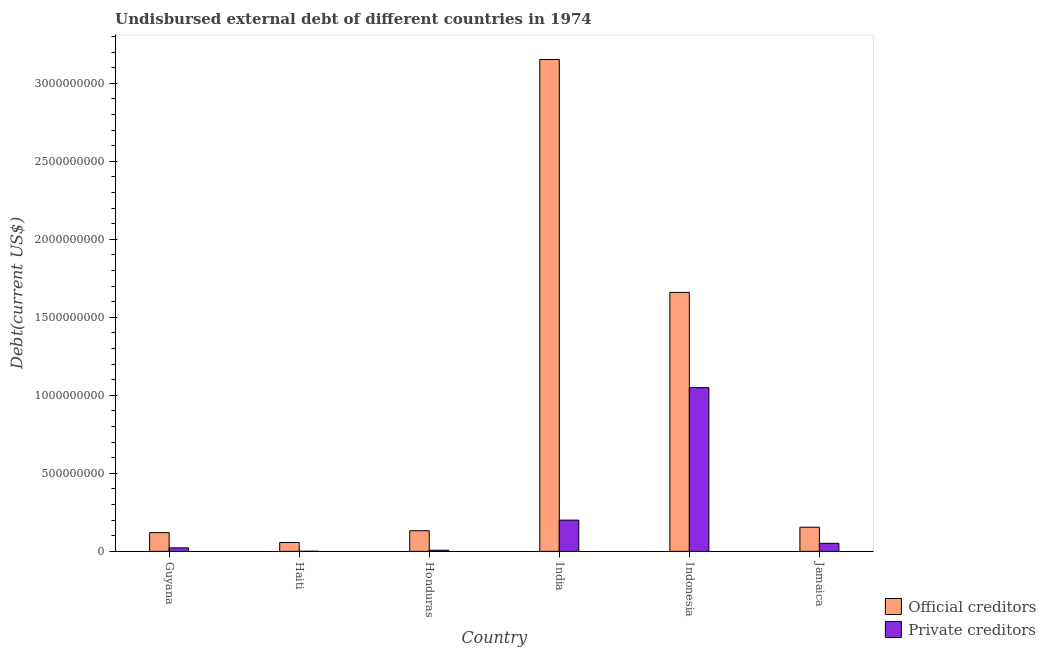How many groups of bars are there?
Keep it short and to the point. 6. Are the number of bars on each tick of the X-axis equal?
Provide a succinct answer. Yes. How many bars are there on the 3rd tick from the left?
Give a very brief answer. 2. How many bars are there on the 6th tick from the right?
Provide a short and direct response. 2. What is the undisbursed external debt of official creditors in India?
Ensure brevity in your answer.  3.15e+09. Across all countries, what is the maximum undisbursed external debt of official creditors?
Your response must be concise. 3.15e+09. Across all countries, what is the minimum undisbursed external debt of official creditors?
Keep it short and to the point. 5.69e+07. In which country was the undisbursed external debt of private creditors minimum?
Provide a succinct answer. Haiti. What is the total undisbursed external debt of official creditors in the graph?
Provide a short and direct response. 5.28e+09. What is the difference between the undisbursed external debt of official creditors in Guyana and that in Jamaica?
Offer a terse response. -3.44e+07. What is the difference between the undisbursed external debt of private creditors in Indonesia and the undisbursed external debt of official creditors in India?
Provide a short and direct response. -2.10e+09. What is the average undisbursed external debt of official creditors per country?
Keep it short and to the point. 8.79e+08. What is the difference between the undisbursed external debt of official creditors and undisbursed external debt of private creditors in Honduras?
Your response must be concise. 1.25e+08. In how many countries, is the undisbursed external debt of private creditors greater than 1200000000 US$?
Give a very brief answer. 0. What is the ratio of the undisbursed external debt of private creditors in Guyana to that in India?
Ensure brevity in your answer.  0.11. Is the difference between the undisbursed external debt of official creditors in Haiti and Honduras greater than the difference between the undisbursed external debt of private creditors in Haiti and Honduras?
Make the answer very short. No. What is the difference between the highest and the second highest undisbursed external debt of official creditors?
Provide a short and direct response. 1.49e+09. What is the difference between the highest and the lowest undisbursed external debt of official creditors?
Ensure brevity in your answer.  3.10e+09. Is the sum of the undisbursed external debt of official creditors in Guyana and Indonesia greater than the maximum undisbursed external debt of private creditors across all countries?
Your response must be concise. Yes. What does the 1st bar from the left in Haiti represents?
Give a very brief answer. Official creditors. What does the 1st bar from the right in Haiti represents?
Make the answer very short. Private creditors. Are all the bars in the graph horizontal?
Offer a terse response. No. How many countries are there in the graph?
Provide a succinct answer. 6. What is the difference between two consecutive major ticks on the Y-axis?
Your answer should be very brief. 5.00e+08. Are the values on the major ticks of Y-axis written in scientific E-notation?
Provide a succinct answer. No. Does the graph contain any zero values?
Give a very brief answer. No. Does the graph contain grids?
Offer a very short reply. No. Where does the legend appear in the graph?
Your answer should be very brief. Bottom right. How are the legend labels stacked?
Your response must be concise. Vertical. What is the title of the graph?
Keep it short and to the point. Undisbursed external debt of different countries in 1974. Does "Age 65(female)" appear as one of the legend labels in the graph?
Your answer should be compact. No. What is the label or title of the Y-axis?
Provide a short and direct response. Debt(current US$). What is the Debt(current US$) of Official creditors in Guyana?
Give a very brief answer. 1.20e+08. What is the Debt(current US$) of Private creditors in Guyana?
Ensure brevity in your answer.  2.25e+07. What is the Debt(current US$) of Official creditors in Haiti?
Your answer should be compact. 5.69e+07. What is the Debt(current US$) of Private creditors in Haiti?
Give a very brief answer. 5.69e+05. What is the Debt(current US$) in Official creditors in Honduras?
Offer a very short reply. 1.32e+08. What is the Debt(current US$) in Private creditors in Honduras?
Offer a very short reply. 7.07e+06. What is the Debt(current US$) of Official creditors in India?
Your answer should be compact. 3.15e+09. What is the Debt(current US$) in Private creditors in India?
Give a very brief answer. 2.00e+08. What is the Debt(current US$) in Official creditors in Indonesia?
Your answer should be compact. 1.66e+09. What is the Debt(current US$) of Private creditors in Indonesia?
Give a very brief answer. 1.05e+09. What is the Debt(current US$) in Official creditors in Jamaica?
Ensure brevity in your answer.  1.55e+08. What is the Debt(current US$) in Private creditors in Jamaica?
Make the answer very short. 5.16e+07. Across all countries, what is the maximum Debt(current US$) of Official creditors?
Your answer should be compact. 3.15e+09. Across all countries, what is the maximum Debt(current US$) in Private creditors?
Make the answer very short. 1.05e+09. Across all countries, what is the minimum Debt(current US$) in Official creditors?
Offer a terse response. 5.69e+07. Across all countries, what is the minimum Debt(current US$) of Private creditors?
Ensure brevity in your answer.  5.69e+05. What is the total Debt(current US$) of Official creditors in the graph?
Keep it short and to the point. 5.28e+09. What is the total Debt(current US$) of Private creditors in the graph?
Offer a terse response. 1.33e+09. What is the difference between the Debt(current US$) in Official creditors in Guyana and that in Haiti?
Offer a terse response. 6.33e+07. What is the difference between the Debt(current US$) of Private creditors in Guyana and that in Haiti?
Your response must be concise. 2.19e+07. What is the difference between the Debt(current US$) of Official creditors in Guyana and that in Honduras?
Provide a short and direct response. -1.19e+07. What is the difference between the Debt(current US$) in Private creditors in Guyana and that in Honduras?
Give a very brief answer. 1.54e+07. What is the difference between the Debt(current US$) in Official creditors in Guyana and that in India?
Ensure brevity in your answer.  -3.03e+09. What is the difference between the Debt(current US$) of Private creditors in Guyana and that in India?
Offer a very short reply. -1.78e+08. What is the difference between the Debt(current US$) in Official creditors in Guyana and that in Indonesia?
Keep it short and to the point. -1.54e+09. What is the difference between the Debt(current US$) in Private creditors in Guyana and that in Indonesia?
Provide a succinct answer. -1.03e+09. What is the difference between the Debt(current US$) in Official creditors in Guyana and that in Jamaica?
Offer a terse response. -3.44e+07. What is the difference between the Debt(current US$) of Private creditors in Guyana and that in Jamaica?
Your answer should be very brief. -2.92e+07. What is the difference between the Debt(current US$) in Official creditors in Haiti and that in Honduras?
Keep it short and to the point. -7.52e+07. What is the difference between the Debt(current US$) in Private creditors in Haiti and that in Honduras?
Give a very brief answer. -6.50e+06. What is the difference between the Debt(current US$) in Official creditors in Haiti and that in India?
Ensure brevity in your answer.  -3.10e+09. What is the difference between the Debt(current US$) of Private creditors in Haiti and that in India?
Your answer should be compact. -2.00e+08. What is the difference between the Debt(current US$) in Official creditors in Haiti and that in Indonesia?
Give a very brief answer. -1.60e+09. What is the difference between the Debt(current US$) in Private creditors in Haiti and that in Indonesia?
Your response must be concise. -1.05e+09. What is the difference between the Debt(current US$) of Official creditors in Haiti and that in Jamaica?
Give a very brief answer. -9.77e+07. What is the difference between the Debt(current US$) of Private creditors in Haiti and that in Jamaica?
Ensure brevity in your answer.  -5.11e+07. What is the difference between the Debt(current US$) of Official creditors in Honduras and that in India?
Your response must be concise. -3.02e+09. What is the difference between the Debt(current US$) in Private creditors in Honduras and that in India?
Provide a short and direct response. -1.93e+08. What is the difference between the Debt(current US$) in Official creditors in Honduras and that in Indonesia?
Offer a terse response. -1.53e+09. What is the difference between the Debt(current US$) in Private creditors in Honduras and that in Indonesia?
Provide a short and direct response. -1.04e+09. What is the difference between the Debt(current US$) of Official creditors in Honduras and that in Jamaica?
Keep it short and to the point. -2.25e+07. What is the difference between the Debt(current US$) in Private creditors in Honduras and that in Jamaica?
Provide a succinct answer. -4.46e+07. What is the difference between the Debt(current US$) of Official creditors in India and that in Indonesia?
Your response must be concise. 1.49e+09. What is the difference between the Debt(current US$) of Private creditors in India and that in Indonesia?
Your answer should be very brief. -8.49e+08. What is the difference between the Debt(current US$) in Official creditors in India and that in Jamaica?
Give a very brief answer. 3.00e+09. What is the difference between the Debt(current US$) of Private creditors in India and that in Jamaica?
Provide a succinct answer. 1.49e+08. What is the difference between the Debt(current US$) in Official creditors in Indonesia and that in Jamaica?
Keep it short and to the point. 1.51e+09. What is the difference between the Debt(current US$) in Private creditors in Indonesia and that in Jamaica?
Your answer should be very brief. 9.98e+08. What is the difference between the Debt(current US$) of Official creditors in Guyana and the Debt(current US$) of Private creditors in Haiti?
Your answer should be very brief. 1.20e+08. What is the difference between the Debt(current US$) of Official creditors in Guyana and the Debt(current US$) of Private creditors in Honduras?
Your response must be concise. 1.13e+08. What is the difference between the Debt(current US$) of Official creditors in Guyana and the Debt(current US$) of Private creditors in India?
Ensure brevity in your answer.  -7.99e+07. What is the difference between the Debt(current US$) in Official creditors in Guyana and the Debt(current US$) in Private creditors in Indonesia?
Provide a short and direct response. -9.29e+08. What is the difference between the Debt(current US$) of Official creditors in Guyana and the Debt(current US$) of Private creditors in Jamaica?
Provide a short and direct response. 6.86e+07. What is the difference between the Debt(current US$) of Official creditors in Haiti and the Debt(current US$) of Private creditors in Honduras?
Ensure brevity in your answer.  4.98e+07. What is the difference between the Debt(current US$) of Official creditors in Haiti and the Debt(current US$) of Private creditors in India?
Ensure brevity in your answer.  -1.43e+08. What is the difference between the Debt(current US$) of Official creditors in Haiti and the Debt(current US$) of Private creditors in Indonesia?
Your answer should be compact. -9.92e+08. What is the difference between the Debt(current US$) of Official creditors in Haiti and the Debt(current US$) of Private creditors in Jamaica?
Your answer should be compact. 5.28e+06. What is the difference between the Debt(current US$) of Official creditors in Honduras and the Debt(current US$) of Private creditors in India?
Make the answer very short. -6.80e+07. What is the difference between the Debt(current US$) in Official creditors in Honduras and the Debt(current US$) in Private creditors in Indonesia?
Your response must be concise. -9.17e+08. What is the difference between the Debt(current US$) of Official creditors in Honduras and the Debt(current US$) of Private creditors in Jamaica?
Provide a short and direct response. 8.05e+07. What is the difference between the Debt(current US$) in Official creditors in India and the Debt(current US$) in Private creditors in Indonesia?
Your response must be concise. 2.10e+09. What is the difference between the Debt(current US$) in Official creditors in India and the Debt(current US$) in Private creditors in Jamaica?
Ensure brevity in your answer.  3.10e+09. What is the difference between the Debt(current US$) in Official creditors in Indonesia and the Debt(current US$) in Private creditors in Jamaica?
Give a very brief answer. 1.61e+09. What is the average Debt(current US$) of Official creditors per country?
Your response must be concise. 8.79e+08. What is the average Debt(current US$) in Private creditors per country?
Your answer should be very brief. 2.22e+08. What is the difference between the Debt(current US$) in Official creditors and Debt(current US$) in Private creditors in Guyana?
Your answer should be very brief. 9.78e+07. What is the difference between the Debt(current US$) in Official creditors and Debt(current US$) in Private creditors in Haiti?
Your response must be concise. 5.63e+07. What is the difference between the Debt(current US$) in Official creditors and Debt(current US$) in Private creditors in Honduras?
Provide a succinct answer. 1.25e+08. What is the difference between the Debt(current US$) in Official creditors and Debt(current US$) in Private creditors in India?
Keep it short and to the point. 2.95e+09. What is the difference between the Debt(current US$) in Official creditors and Debt(current US$) in Private creditors in Indonesia?
Make the answer very short. 6.10e+08. What is the difference between the Debt(current US$) of Official creditors and Debt(current US$) of Private creditors in Jamaica?
Your response must be concise. 1.03e+08. What is the ratio of the Debt(current US$) in Official creditors in Guyana to that in Haiti?
Provide a succinct answer. 2.11. What is the ratio of the Debt(current US$) in Private creditors in Guyana to that in Haiti?
Your answer should be very brief. 39.49. What is the ratio of the Debt(current US$) in Official creditors in Guyana to that in Honduras?
Your answer should be very brief. 0.91. What is the ratio of the Debt(current US$) of Private creditors in Guyana to that in Honduras?
Your answer should be compact. 3.18. What is the ratio of the Debt(current US$) in Official creditors in Guyana to that in India?
Make the answer very short. 0.04. What is the ratio of the Debt(current US$) in Private creditors in Guyana to that in India?
Keep it short and to the point. 0.11. What is the ratio of the Debt(current US$) in Official creditors in Guyana to that in Indonesia?
Offer a terse response. 0.07. What is the ratio of the Debt(current US$) of Private creditors in Guyana to that in Indonesia?
Provide a succinct answer. 0.02. What is the ratio of the Debt(current US$) in Official creditors in Guyana to that in Jamaica?
Provide a short and direct response. 0.78. What is the ratio of the Debt(current US$) of Private creditors in Guyana to that in Jamaica?
Offer a terse response. 0.44. What is the ratio of the Debt(current US$) in Official creditors in Haiti to that in Honduras?
Keep it short and to the point. 0.43. What is the ratio of the Debt(current US$) in Private creditors in Haiti to that in Honduras?
Keep it short and to the point. 0.08. What is the ratio of the Debt(current US$) of Official creditors in Haiti to that in India?
Offer a terse response. 0.02. What is the ratio of the Debt(current US$) in Private creditors in Haiti to that in India?
Keep it short and to the point. 0. What is the ratio of the Debt(current US$) of Official creditors in Haiti to that in Indonesia?
Your answer should be very brief. 0.03. What is the ratio of the Debt(current US$) of Private creditors in Haiti to that in Indonesia?
Offer a very short reply. 0. What is the ratio of the Debt(current US$) of Official creditors in Haiti to that in Jamaica?
Provide a short and direct response. 0.37. What is the ratio of the Debt(current US$) of Private creditors in Haiti to that in Jamaica?
Give a very brief answer. 0.01. What is the ratio of the Debt(current US$) in Official creditors in Honduras to that in India?
Offer a terse response. 0.04. What is the ratio of the Debt(current US$) in Private creditors in Honduras to that in India?
Offer a very short reply. 0.04. What is the ratio of the Debt(current US$) in Official creditors in Honduras to that in Indonesia?
Your response must be concise. 0.08. What is the ratio of the Debt(current US$) of Private creditors in Honduras to that in Indonesia?
Provide a succinct answer. 0.01. What is the ratio of the Debt(current US$) in Official creditors in Honduras to that in Jamaica?
Give a very brief answer. 0.85. What is the ratio of the Debt(current US$) of Private creditors in Honduras to that in Jamaica?
Offer a very short reply. 0.14. What is the ratio of the Debt(current US$) in Official creditors in India to that in Indonesia?
Your answer should be compact. 1.9. What is the ratio of the Debt(current US$) in Private creditors in India to that in Indonesia?
Offer a terse response. 0.19. What is the ratio of the Debt(current US$) in Official creditors in India to that in Jamaica?
Your response must be concise. 20.39. What is the ratio of the Debt(current US$) of Private creditors in India to that in Jamaica?
Keep it short and to the point. 3.88. What is the ratio of the Debt(current US$) in Official creditors in Indonesia to that in Jamaica?
Provide a short and direct response. 10.73. What is the ratio of the Debt(current US$) in Private creditors in Indonesia to that in Jamaica?
Keep it short and to the point. 20.32. What is the difference between the highest and the second highest Debt(current US$) in Official creditors?
Provide a succinct answer. 1.49e+09. What is the difference between the highest and the second highest Debt(current US$) of Private creditors?
Keep it short and to the point. 8.49e+08. What is the difference between the highest and the lowest Debt(current US$) in Official creditors?
Provide a short and direct response. 3.10e+09. What is the difference between the highest and the lowest Debt(current US$) in Private creditors?
Provide a succinct answer. 1.05e+09. 